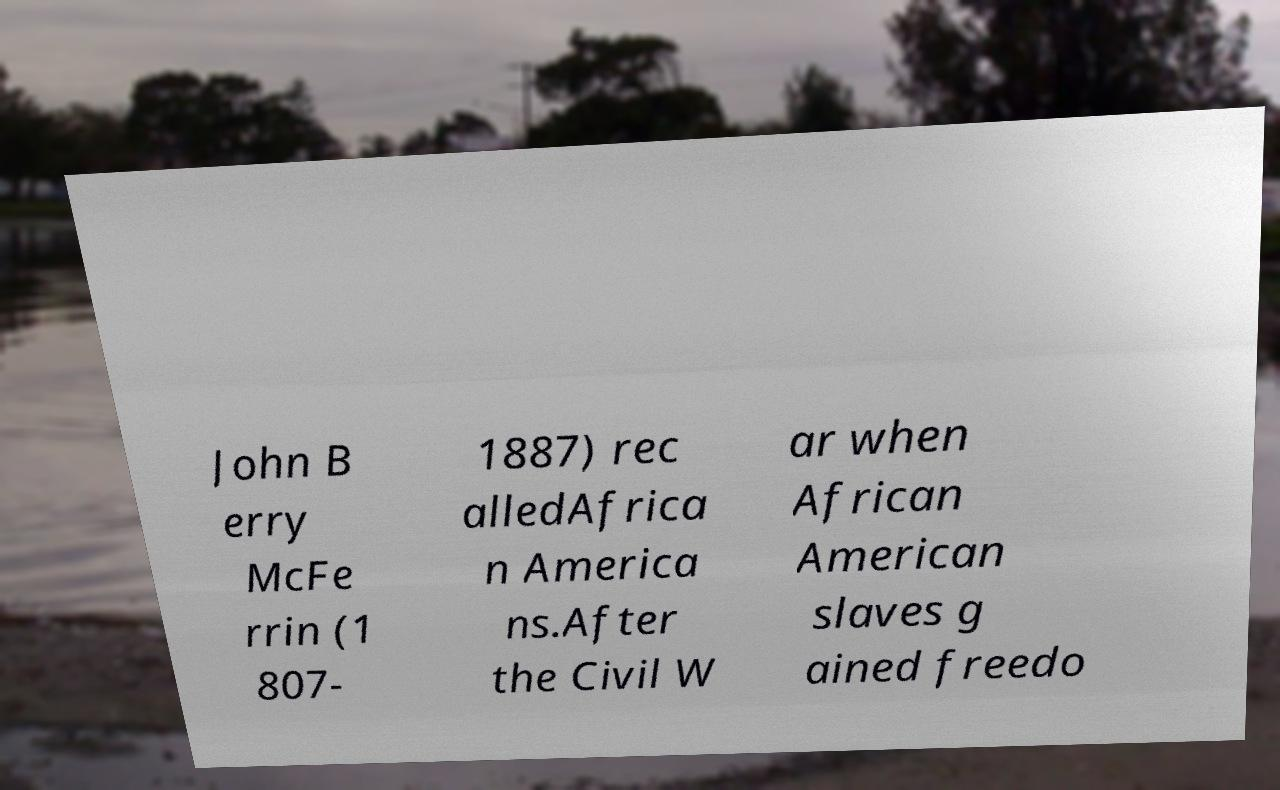I need the written content from this picture converted into text. Can you do that? John B erry McFe rrin (1 807- 1887) rec alledAfrica n America ns.After the Civil W ar when African American slaves g ained freedo 